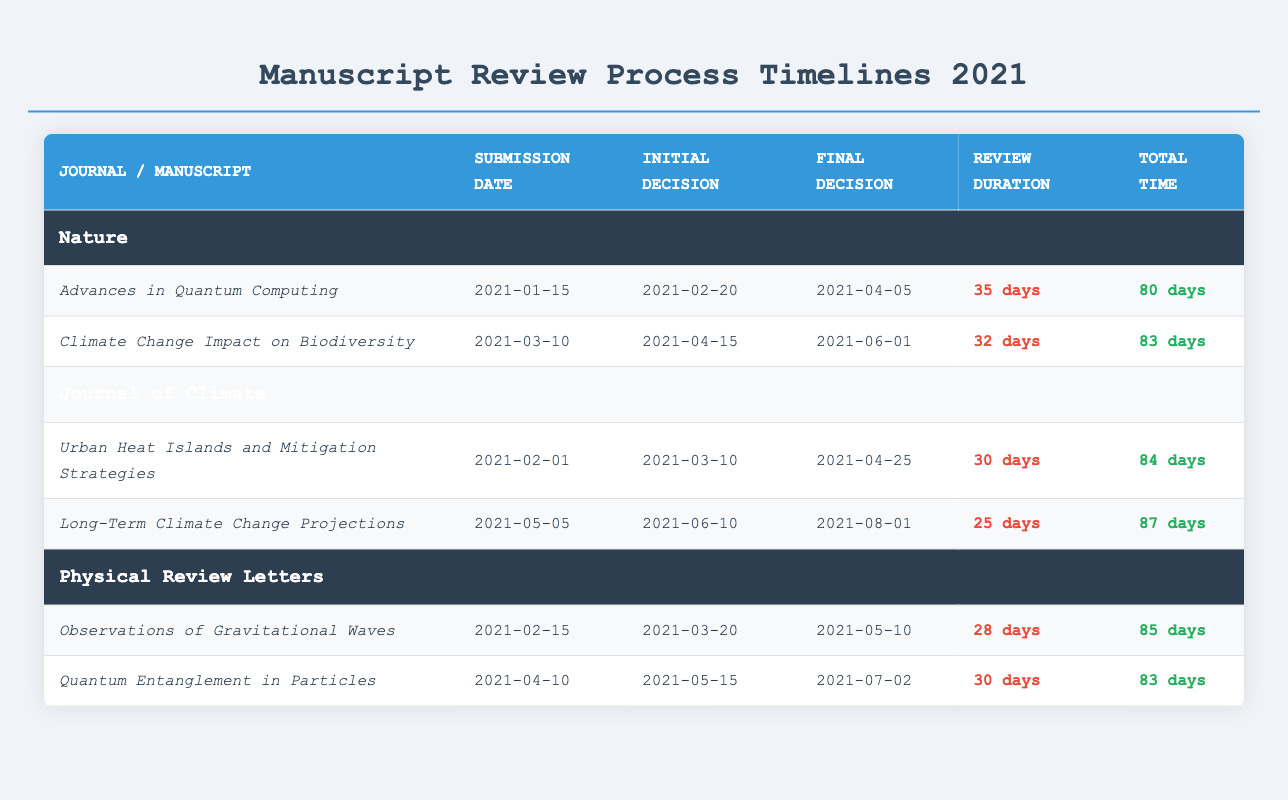What is the total review duration for the manuscript "Advances in Quantum Computing"? The review duration for "Advances in Quantum Computing" is listed in the table as 35 days.
Answer: 35 days Which journal had the longest total time from submission to final decision? By comparing the total time for each journal, "Long-Term Climate Change Projections" (Journal of Climate) had the longest total time of 87 days.
Answer: Journal of Climate Did the manuscript "Quantum Entanglement in Particles" have a longer review duration than "Urban Heat Islands and Mitigation Strategies"? The review duration for "Quantum Entanglement in Particles" is 30 days, while "Urban Heat Islands and Mitigation Strategies" is 30 days as well; they are equal.
Answer: No What is the average total time for manuscripts submitted to Nature? The total time for the two manuscripts submitted to Nature are 80 days and 83 days. The average is (80 + 83) / 2 = 81.5 days.
Answer: 81.5 days How many days was the review duration of the manuscript "Climate Change Impact on Biodiversity"? The review duration for "Climate Change Impact on Biodiversity" is clearly mentioned in the table as 32 days.
Answer: 32 days Which manuscript took the shortest time from initial decision to final decision? "Long-Term Climate Change Projections" had the shortest time from initial decision (June 10) to final decision (August 01), which is 52 days compared to other manuscripts.
Answer: Long-Term Climate Change Projections Is the total time for "Observations of Gravitational Waves" greater than 85 days? The total time for "Observations of Gravitational Waves" is stated as 85 days; therefore, it is not greater than 85 days.
Answer: No What is the difference in total review duration between the manuscript "Quantum Entanglement in Particles" and "Observations of Gravitational Waves"? "Quantum Entanglement in Particles" has a review duration of 30 days, and "Observations of Gravitational Waves" has a review duration of 28 days. The difference is 30 - 28 = 2 days.
Answer: 2 days How many manuscripts had a total time of over 85 days? By reviewing the total time for each manuscript, we find that "Long-Term Climate Change Projections" (87 days) and "Urban Heat Islands and Mitigation Strategies" (84 days) and "Observations of Gravitational Waves" (85 days) had total times over or at 85 days, totaling 3 manuscripts.
Answer: 3 manuscripts 